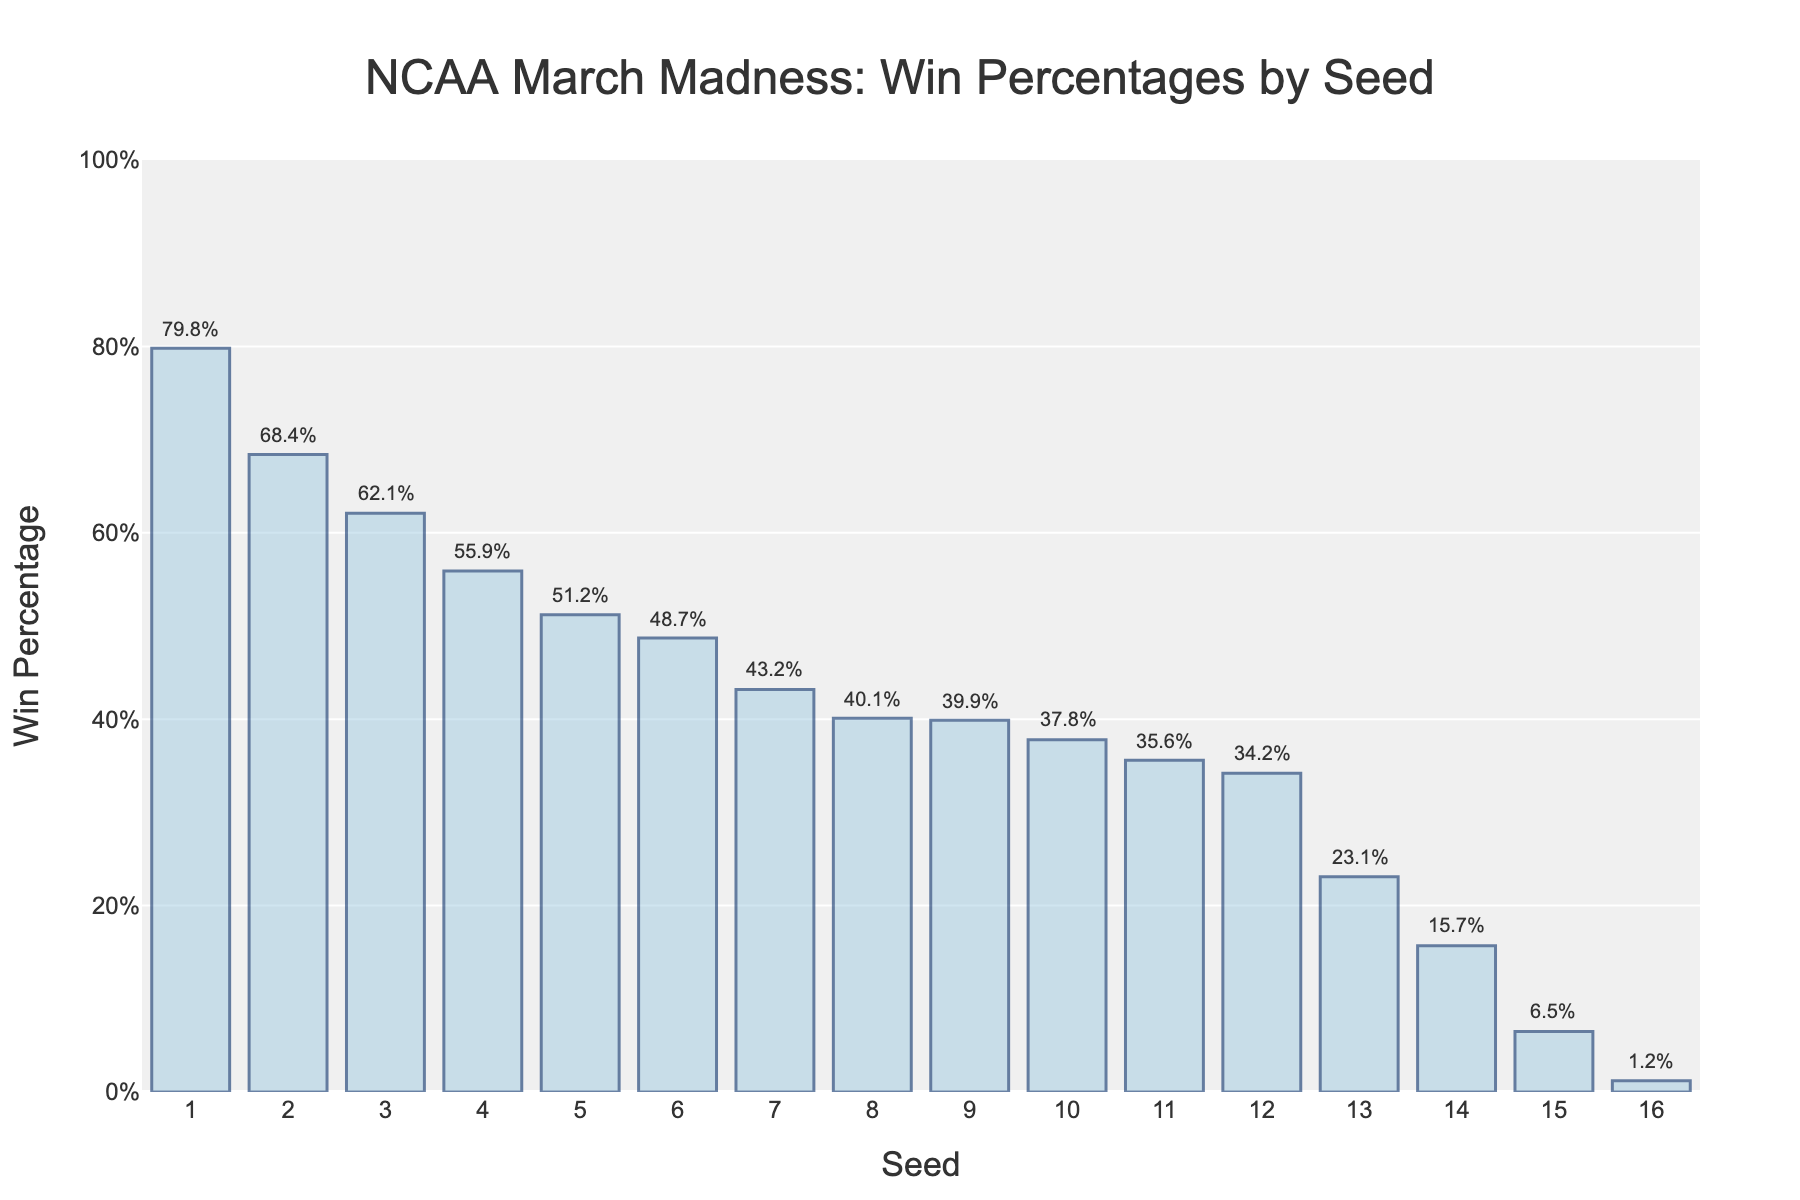What seed number has the highest win percentage? The highest bar in the chart corresponds to seed number 1. The win percentage for seed number 1 is 79.8%. Therefore, seed number 1 has the highest win percentage.
Answer: Seed number 1 What is the win percentage difference between seed number 1 and seed number 16? The win percentage for seed number 1 is 79.8% and for seed number 16 is 1.2%. The difference is calculated by subtracting 1.2 from 79.8, which equals 78.6.
Answer: 78.6% Which seeds have win percentages greater than 50%? By observing the bars that extend above the 50% mark, the seeds 1 through 5 have win percentages greater than 50%.
Answer: Seeds 1, 2, 3, 4, 5 What is the average win percentage for seed numbers 8, 9, and 10? The win percentages for seeds 8, 9, and 10 are 40.1%, 39.9%, and 37.8%, respectively. Summing these percentages together results in 117.8%. Dividing this sum by 3 gives an average of 39.27%.
Answer: 39.27% Do any seed numbers have almost equal win percentages? Seeds 8 and 9 have win percentages of 40.1% and 39.9%, respectively. These values are very close to each other with a difference of only 0.2%.
Answer: Seeds 8 and 9 Which seed has the lowest win percentage, and what is it? The shortest bar on the chart corresponds to seed number 16, with a win percentage of 1.2%. Therefore, seed 16 has the lowest win percentage.
Answer: Seed number 16, 1.2% What is the win percentage range for seeds ranked 11 through 15? The win percentages for seeds 11 through 15 are 35.6%, 34.2%, 23.1%, 15.7%, and 6.5% respectively. The range is calculated by subtracting the lowest percentage (6.5%) from the highest percentage (35.6%), resulting in 29.1%.
Answer: 29.1% Which seed numbers have a win percentage below 20%? Bars that do not reach the 20% mark correspond to seeds 13, 14, 15, and 16 with win percentages of 23.1%, 15.7%, 6.5%, and 1.2% respectively. However, only 14, 15, and 16 are below 20%.
Answer: Seeds 14, 15, 16 How many seed numbers have a win percentage above 60%? By counting the bars that exceed the 60% level, we find that seeds 1, 2, and 3 have win percentages above 60%. There are 3 such seed numbers.
Answer: 3 